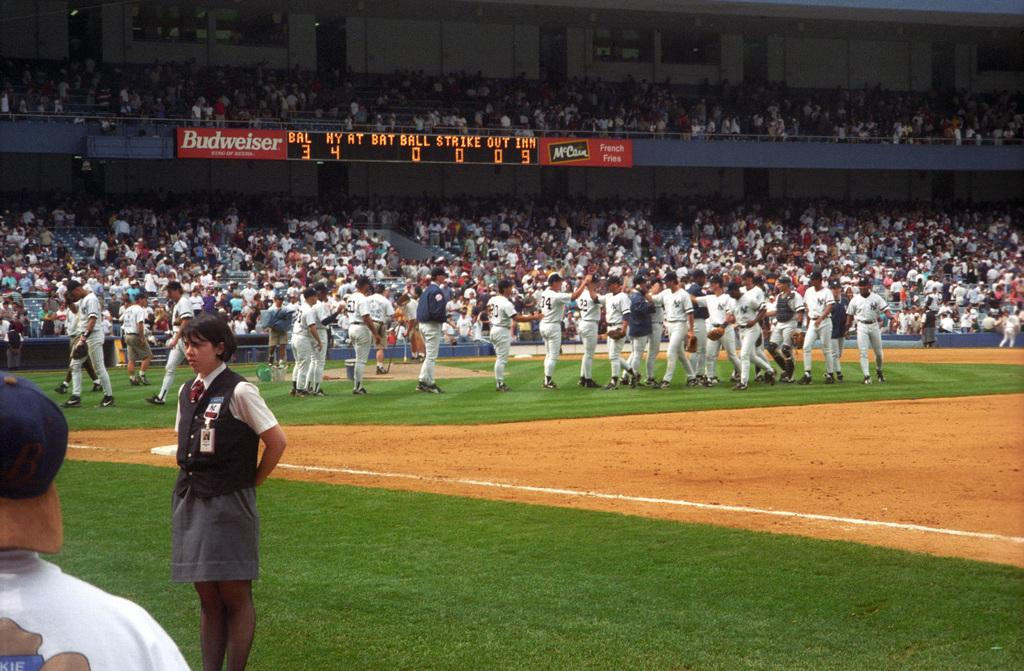<image>
Create a compact narrative representing the image presented. Professional baseball players stand on the field in a stadium with a Budweiser banner next to the scoreboard. 